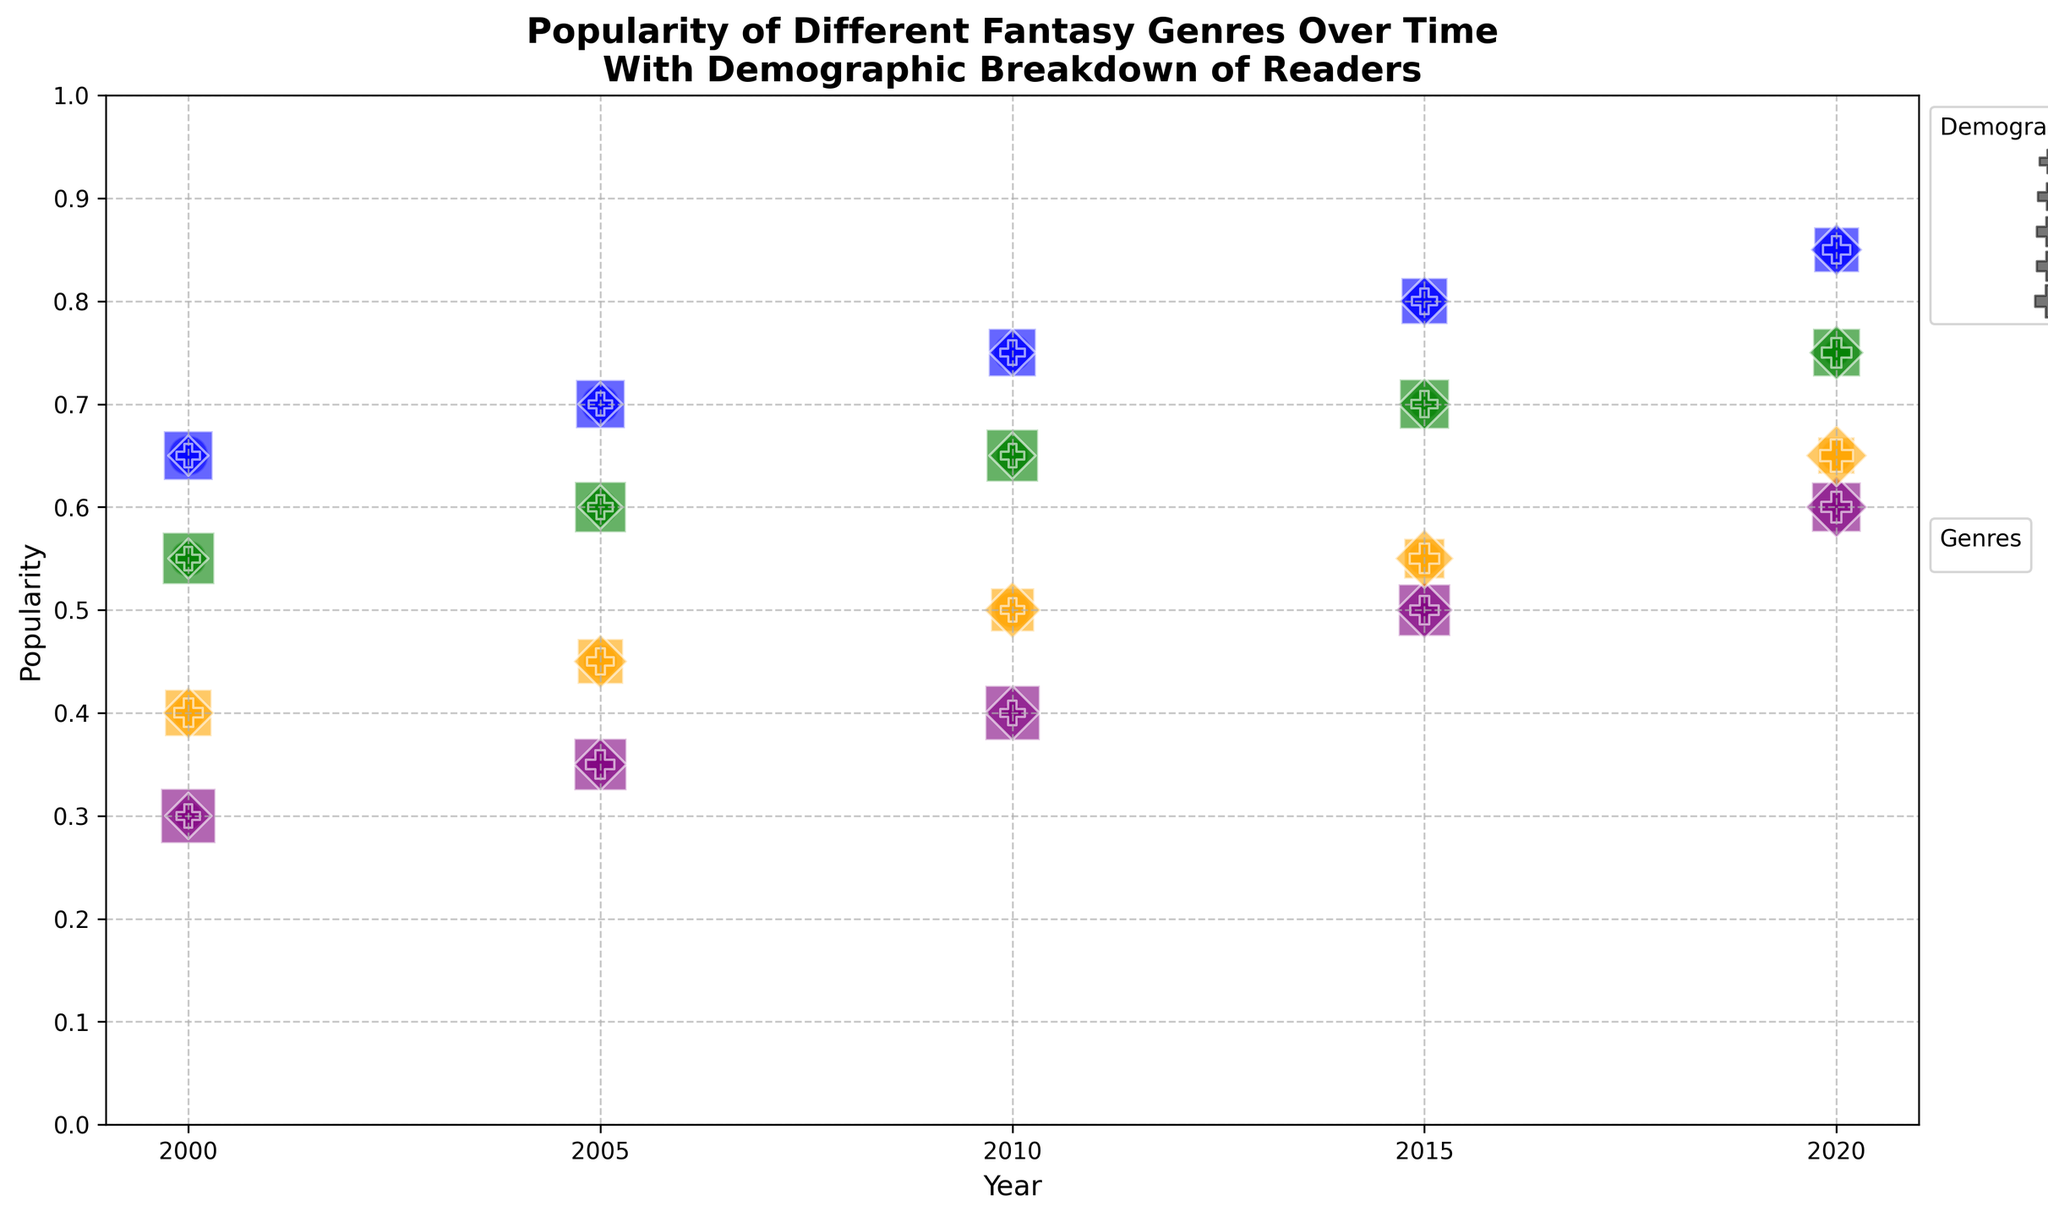What's the most popular genre in 2020 and its popularity score? Look at the year 2020 and compare the popularity scores of all genres. High Fantasy has the highest popularity score.
Answer: High Fantasy with a score of 0.85 Which age group has the highest demographic percentage for Urban Fantasy in 2005? Look at the markers for Urban Fantasy in 2005 and compare their sizes. The biggest marker indicates the highest demographic percentage. The square marker for 18-35 age group is the largest.
Answer: 18-35 In 2015, how does the popularity of Dark Fantasy compare to Sword and Sorcery? Look at the markers for Dark Fantasy and Sword and Sorcery in 2015. The Dark Fantasy marker is at 0.50, and Sword and Sorcery is at 0.55. Sword and Sorcery is more popular.
Answer: Sword and Sorcery is more popular Which genre's readership among the 18-35 age group increased the most from 2000 to 2020? Calculate the difference in popularity scores for the 18-35 age group from 2000 to 2020 for each genre. High Fantasy increased from 0.65 to 0.85, which is the highest increase of 0.20.
Answer: High Fantasy What is the average popularity score of Urban Fantasy from 2000 to 2020? Calculate the mean of Urban Fantasy's popularity scores over the years: (0.55 + 0.60 + 0.65 + 0.70 + 0.75) / 5 = 3.25 / 5 = 0.65
Answer: 0.65 What's the difference in demographic percentage between the youngest and oldest age groups for High Fantasy in 2020? Look at the demographic percentages for High Fantasy in 2020 for Under 18 (0.23) and 50+ (0.14). The difference is 0.23 - 0.14.
Answer: 0.09 Which year experienced the highest increase in popularity for High Fantasy? Compare the year-on-year changes in popularity for High Fantasy. The largest increase is between 2015 (0.80) and 2020 (0.85), which is 0.05.
Answer: 2015 to 2020 How does the size of the marker for Urban Fantasy in 2010 for the Under 18 age group visually compare to the size of the same marker in 2000? Compare the marker sizes for Under 18 in 2010 and 2000 for Urban Fantasy. The marker in 2010 is smaller (0.20) compared to 2000 (0.25).
Answer: Smaller in 2010 What is the trend in popularity for Dark Fantasy from 2000 to 2020? Look at the popularity scores for Dark Fantasy over the years: 0.30 in 2000, 0.35 in 2005, 0.40 in 2010, 0.50 in 2015, and 0.60 in 2020. The trend is increasing.
Answer: Increasing In 2020, which genre has the most evenly distributed readership across all age groups? Compare the demographic percentages across all age groups for each genre. Sword and Sorcery has the most similar percentages (Under 18: 0.20, 18-35: 0.25, 35-50: 0.35, 50+: 0.20).
Answer: Sword and Sorcery 